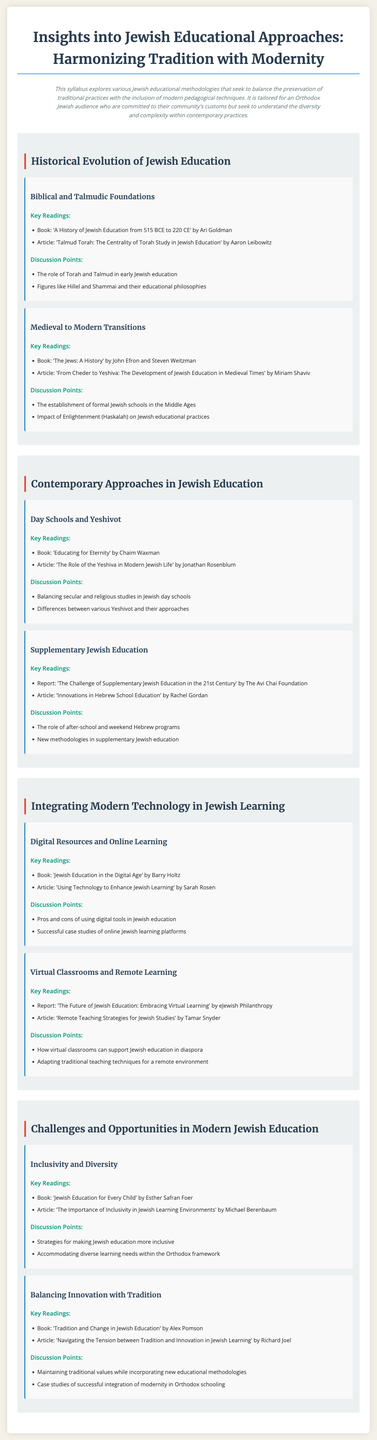What is the title of the syllabus? The title of the syllabus is clearly stated at the top of the document under the heading.
Answer: Insights into Jewish Educational Approaches: Harmonizing Tradition with Modernity Who is the author of the book 'A History of Jewish Education from 515 BCE to 220 CE'? The author is mentioned in the key readings section for the topic regarding Biblical and Talmudic foundations.
Answer: Ari Goldman What is one of the discussion points in the topic 'Digital Resources and Online Learning'? The discussion points for each topic provide specific aspects to consider, listed in the document.
Answer: Pros and cons of using digital tools in Jewish education What type of educational institution is discussed in the topic 'Day Schools and Yeshivot'? The syllabus covers this in the context of contemporary Jewish education.
Answer: Jewish day schools and Yeshivot Which article emphasizes the importance of inclusivity in Jewish learning environments? The document lists key readings that can be referenced for further insights into topics.
Answer: The Importance of Inclusivity in Jewish Learning Environments How many units are covered in this syllabus? The number of units can be determined by counting the major sections presented in the syllabus.
Answer: Four What does the discussion point 'Maintaining traditional values while incorporating new educational methodologies' pertain to? This is a discussion point under the topic that addresses the tension between tradition and modernity in education.
Answer: Balancing Innovation with Tradition 